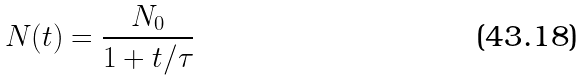<formula> <loc_0><loc_0><loc_500><loc_500>N ( t ) = \frac { N _ { 0 } } { 1 + t / \tau }</formula> 